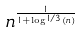Convert formula to latex. <formula><loc_0><loc_0><loc_500><loc_500>n ^ { \frac { 1 } { 1 + \log ^ { 1 / 3 } ( n ) } }</formula> 